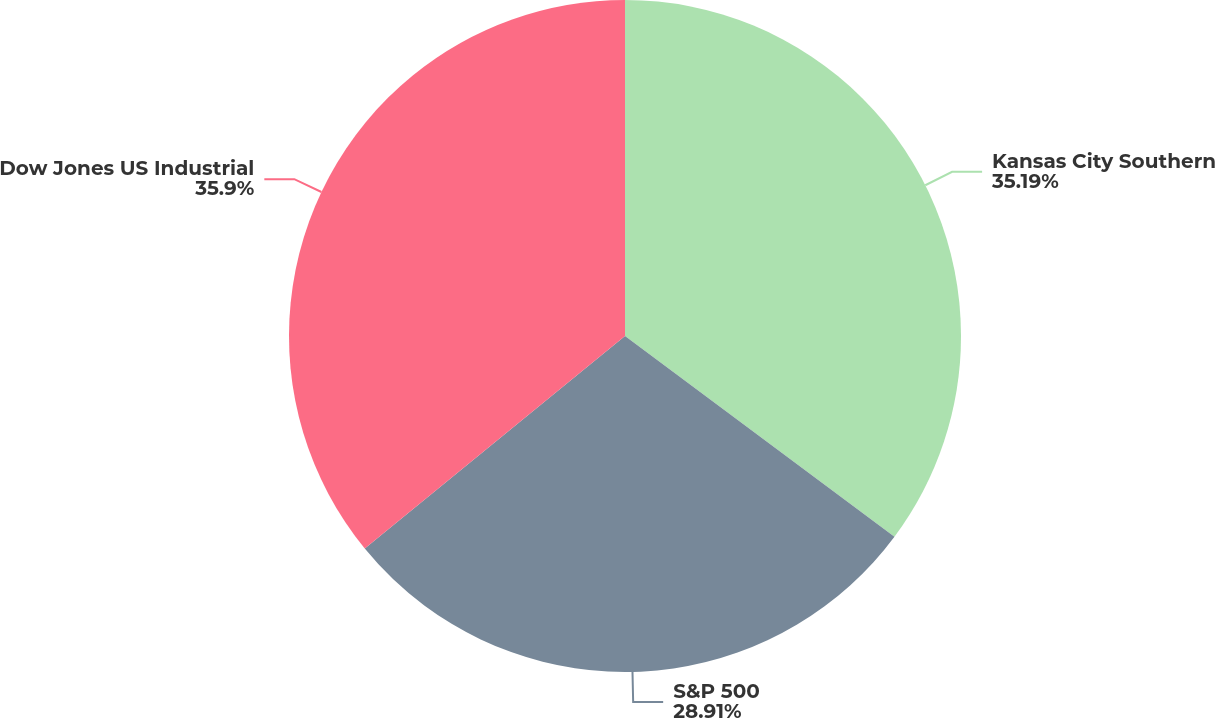<chart> <loc_0><loc_0><loc_500><loc_500><pie_chart><fcel>Kansas City Southern<fcel>S&P 500<fcel>Dow Jones US Industrial<nl><fcel>35.19%<fcel>28.91%<fcel>35.9%<nl></chart> 